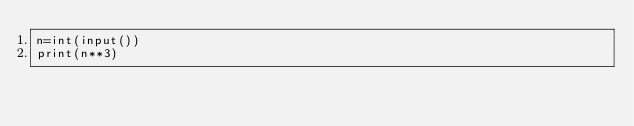<code> <loc_0><loc_0><loc_500><loc_500><_Python_>n=int(input())
print(n**3)</code> 